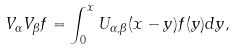<formula> <loc_0><loc_0><loc_500><loc_500>V _ { \alpha } V _ { \beta } f = \int _ { 0 } ^ { x } U _ { \alpha , \beta } ( x - y ) f ( y ) d y ,</formula> 